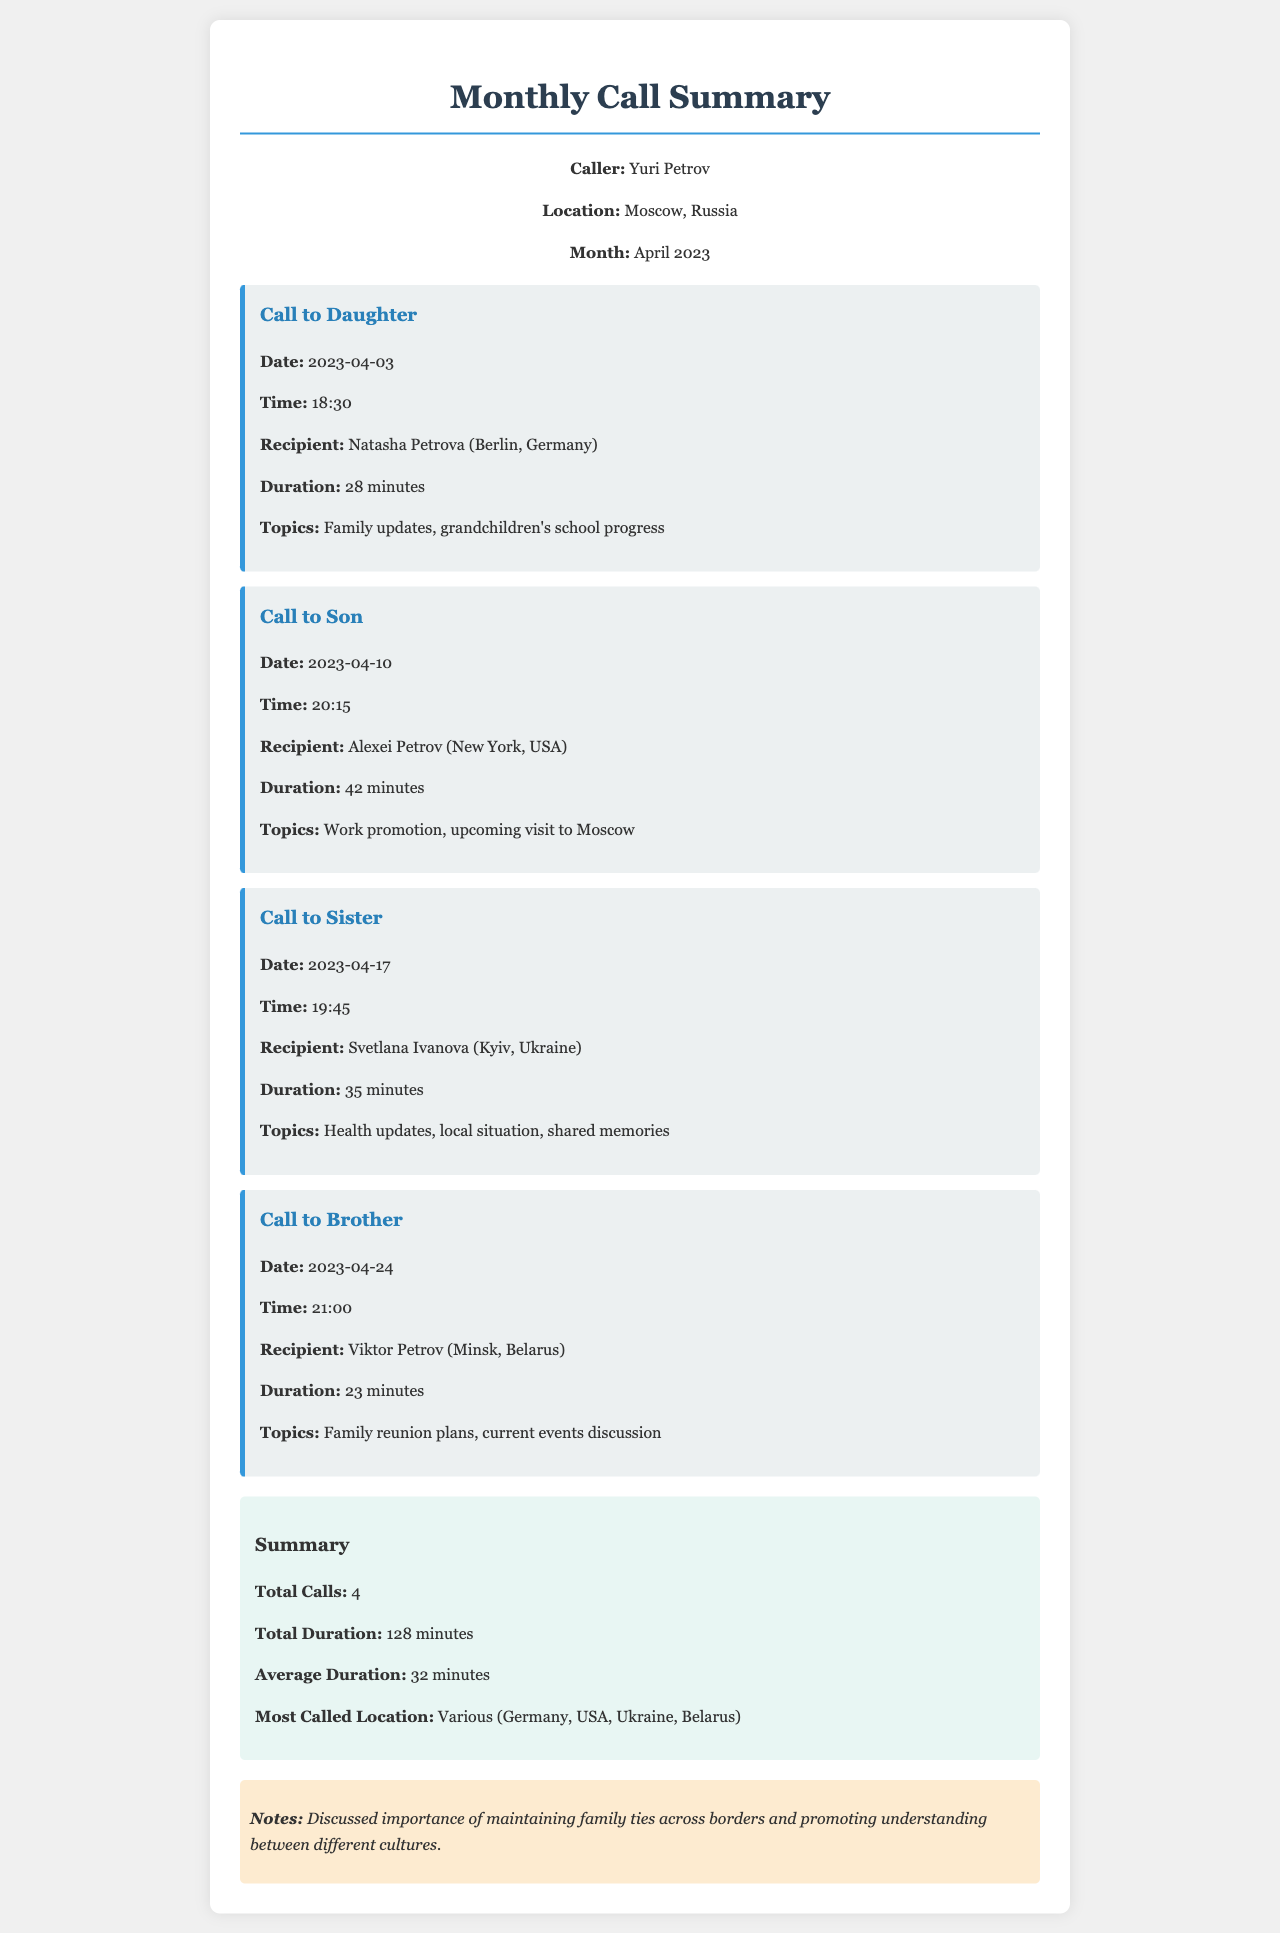What was the date of the call to Natasha Petrov? The date of the call to Natasha Petrov is specifically stated in the document.
Answer: 2023-04-03 How long was the call to Alexei Petrov? The duration of the call to Alexei Petrov is mentioned directly in the call details.
Answer: 42 minutes Who is the recipient of the call made on 2023-04-17? The document provides clear details about the recipient for each call, including this one.
Answer: Svetlana Ivanova What is the total duration of all calls made? The total duration of calls is specifically calculated and presented in the summary section.
Answer: 128 minutes Which family member lives in New York? The document explicitly mentions the name of the family member who is in New York.
Answer: Alexei Petrov How many calls were made in total during April 2023? The total number of calls is stated in the summary, capturing all long-distance calls made.
Answer: 4 What were the topics discussed during the call to Viktor Petrov? The document describes the topics addressed during each call, including this one.
Answer: Family reunion plans, current events discussion What does the notes section emphasize? The notes section summarizes key points mentioned throughout the document, focusing on underlying themes.
Answer: Importance of maintaining family ties across borders 